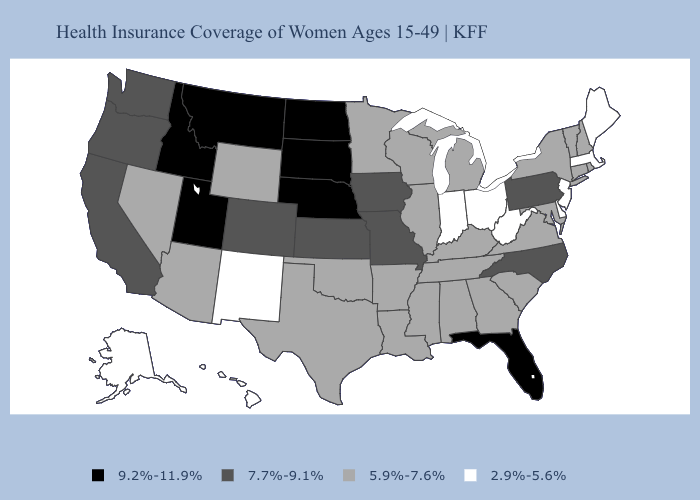Name the states that have a value in the range 7.7%-9.1%?
Quick response, please. California, Colorado, Iowa, Kansas, Missouri, North Carolina, Oregon, Pennsylvania, Washington. Which states hav the highest value in the South?
Answer briefly. Florida. What is the value of New Mexico?
Answer briefly. 2.9%-5.6%. What is the highest value in the MidWest ?
Quick response, please. 9.2%-11.9%. What is the value of Nebraska?
Concise answer only. 9.2%-11.9%. What is the value of Washington?
Be succinct. 7.7%-9.1%. What is the highest value in the USA?
Give a very brief answer. 9.2%-11.9%. Among the states that border Pennsylvania , which have the lowest value?
Be succinct. Delaware, New Jersey, Ohio, West Virginia. Name the states that have a value in the range 2.9%-5.6%?
Give a very brief answer. Alaska, Delaware, Hawaii, Indiana, Maine, Massachusetts, New Jersey, New Mexico, Ohio, West Virginia. Does the map have missing data?
Write a very short answer. No. Name the states that have a value in the range 5.9%-7.6%?
Concise answer only. Alabama, Arizona, Arkansas, Connecticut, Georgia, Illinois, Kentucky, Louisiana, Maryland, Michigan, Minnesota, Mississippi, Nevada, New Hampshire, New York, Oklahoma, Rhode Island, South Carolina, Tennessee, Texas, Vermont, Virginia, Wisconsin, Wyoming. Name the states that have a value in the range 2.9%-5.6%?
Answer briefly. Alaska, Delaware, Hawaii, Indiana, Maine, Massachusetts, New Jersey, New Mexico, Ohio, West Virginia. What is the value of Alaska?
Quick response, please. 2.9%-5.6%. What is the highest value in the USA?
Be succinct. 9.2%-11.9%. What is the value of New York?
Write a very short answer. 5.9%-7.6%. 